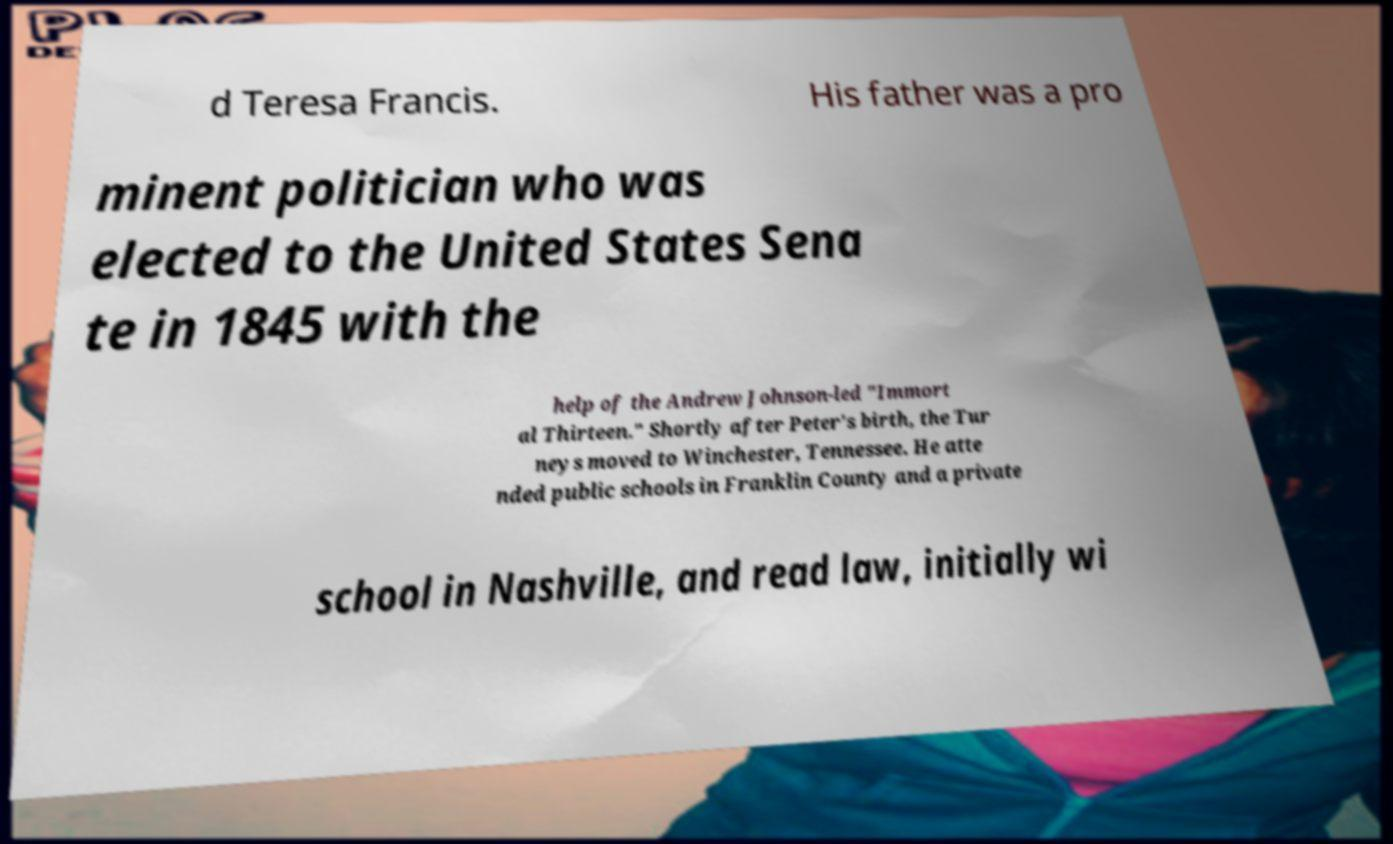Please identify and transcribe the text found in this image. d Teresa Francis. His father was a pro minent politician who was elected to the United States Sena te in 1845 with the help of the Andrew Johnson-led "Immort al Thirteen." Shortly after Peter's birth, the Tur neys moved to Winchester, Tennessee. He atte nded public schools in Franklin County and a private school in Nashville, and read law, initially wi 